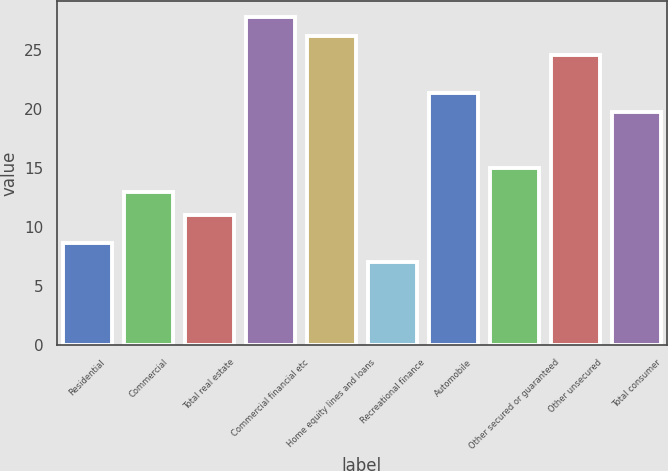Convert chart. <chart><loc_0><loc_0><loc_500><loc_500><bar_chart><fcel>Residential<fcel>Commercial<fcel>Total real estate<fcel>Commercial financial etc<fcel>Home equity lines and loans<fcel>Recreational finance<fcel>Automobile<fcel>Other secured or guaranteed<fcel>Other unsecured<fcel>Total consumer<nl><fcel>8.6<fcel>13<fcel>11<fcel>27.8<fcel>26.2<fcel>7<fcel>21.4<fcel>15<fcel>24.6<fcel>19.8<nl></chart> 